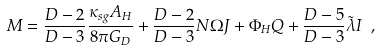<formula> <loc_0><loc_0><loc_500><loc_500>M = \frac { D - 2 } { D - 3 } \frac { \kappa _ { s g } A _ { H } } { 8 \pi G _ { D } } + \frac { D - 2 } { D - 3 } N \Omega J + \Phi _ { H } Q + \frac { D - 5 } { D - 3 } { \tilde { \lambda } } I \ ,</formula> 